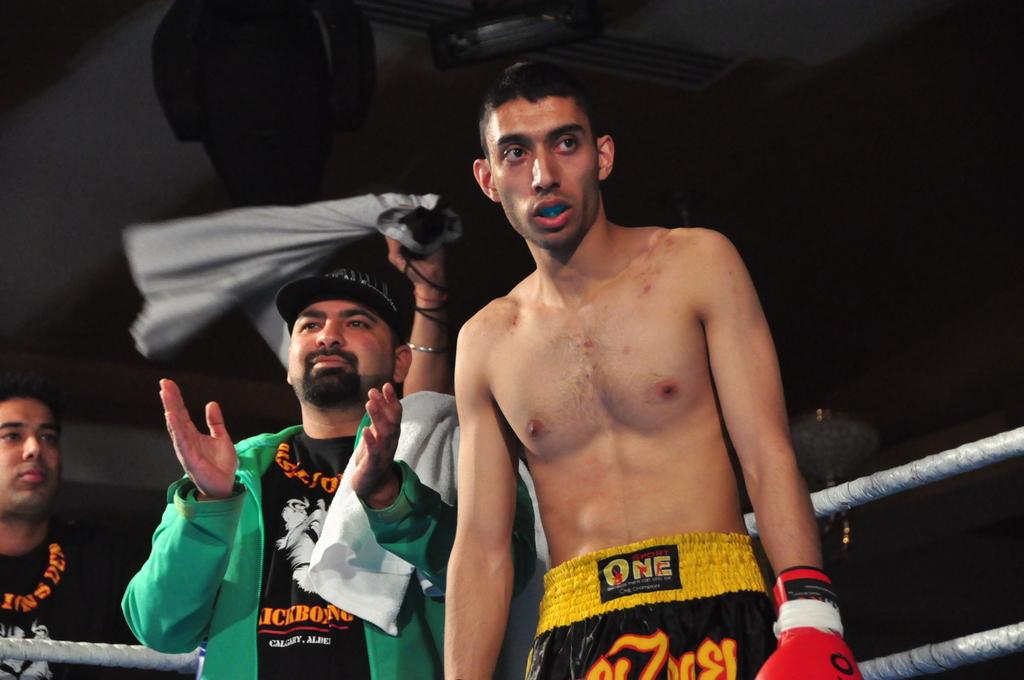<image>
Describe the image concisely. A fighter sponsored by One Sport is in the ring. 